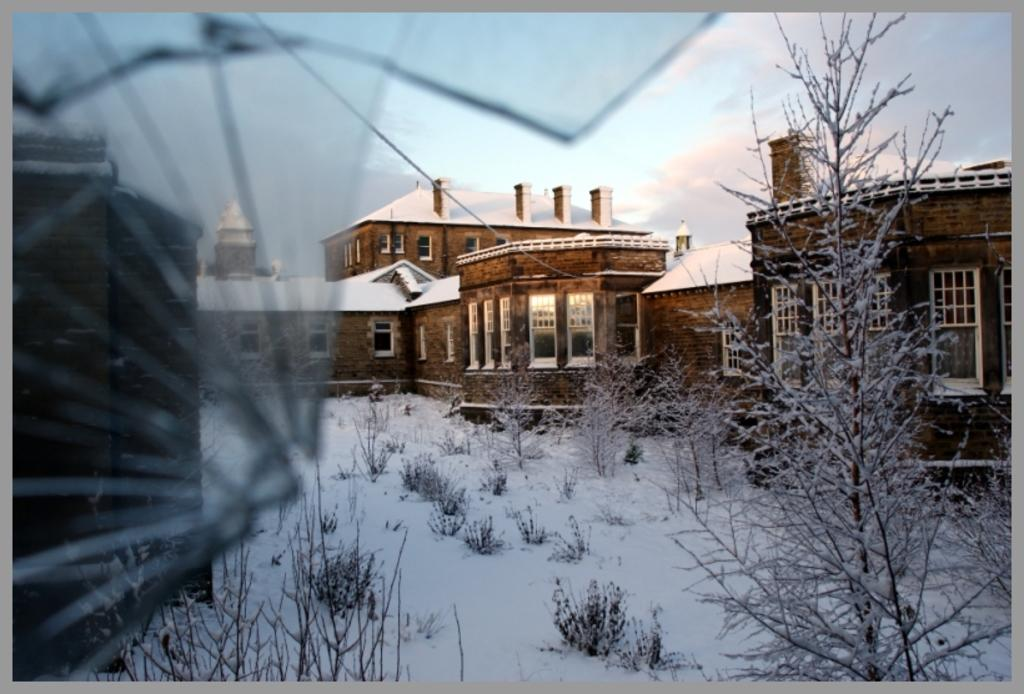What type of structure is visible in the image? There is a house in the image. What feature of the house is mentioned in the facts? The house has windows. What is covering the roof of the house? There is snow on the roof of the house. What is the condition of the ground in the image? There is snow on the ground in the image. What type of vegetation is present on the ground in the image? There are plants on the ground in the image. What type of curtain is hanging in the window of the house in the image? There is no information about curtains in the image, so we cannot determine if there are any curtains hanging in the windows. 